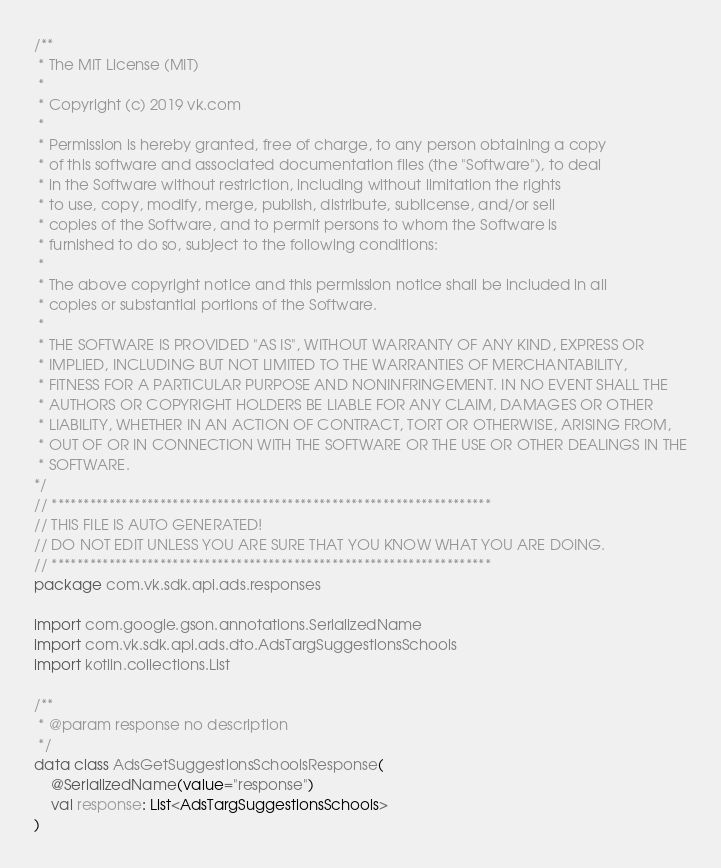Convert code to text. <code><loc_0><loc_0><loc_500><loc_500><_Kotlin_>/**
 * The MIT License (MIT)
 *
 * Copyright (c) 2019 vk.com
 *
 * Permission is hereby granted, free of charge, to any person obtaining a copy
 * of this software and associated documentation files (the "Software"), to deal
 * in the Software without restriction, including without limitation the rights
 * to use, copy, modify, merge, publish, distribute, sublicense, and/or sell
 * copies of the Software, and to permit persons to whom the Software is
 * furnished to do so, subject to the following conditions:
 *
 * The above copyright notice and this permission notice shall be included in all
 * copies or substantial portions of the Software.
 *
 * THE SOFTWARE IS PROVIDED "AS IS", WITHOUT WARRANTY OF ANY KIND, EXPRESS OR
 * IMPLIED, INCLUDING BUT NOT LIMITED TO THE WARRANTIES OF MERCHANTABILITY,
 * FITNESS FOR A PARTICULAR PURPOSE AND NONINFRINGEMENT. IN NO EVENT SHALL THE
 * AUTHORS OR COPYRIGHT HOLDERS BE LIABLE FOR ANY CLAIM, DAMAGES OR OTHER
 * LIABILITY, WHETHER IN AN ACTION OF CONTRACT, TORT OR OTHERWISE, ARISING FROM,
 * OUT OF OR IN CONNECTION WITH THE SOFTWARE OR THE USE OR OTHER DEALINGS IN THE
 * SOFTWARE.
*/
// *********************************************************************
// THIS FILE IS AUTO GENERATED!
// DO NOT EDIT UNLESS YOU ARE SURE THAT YOU KNOW WHAT YOU ARE DOING.
// *********************************************************************
package com.vk.sdk.api.ads.responses

import com.google.gson.annotations.SerializedName
import com.vk.sdk.api.ads.dto.AdsTargSuggestionsSchools
import kotlin.collections.List

/**
 * @param response no description
 */
data class AdsGetSuggestionsSchoolsResponse(
    @SerializedName(value="response")
    val response: List<AdsTargSuggestionsSchools>
)
</code> 